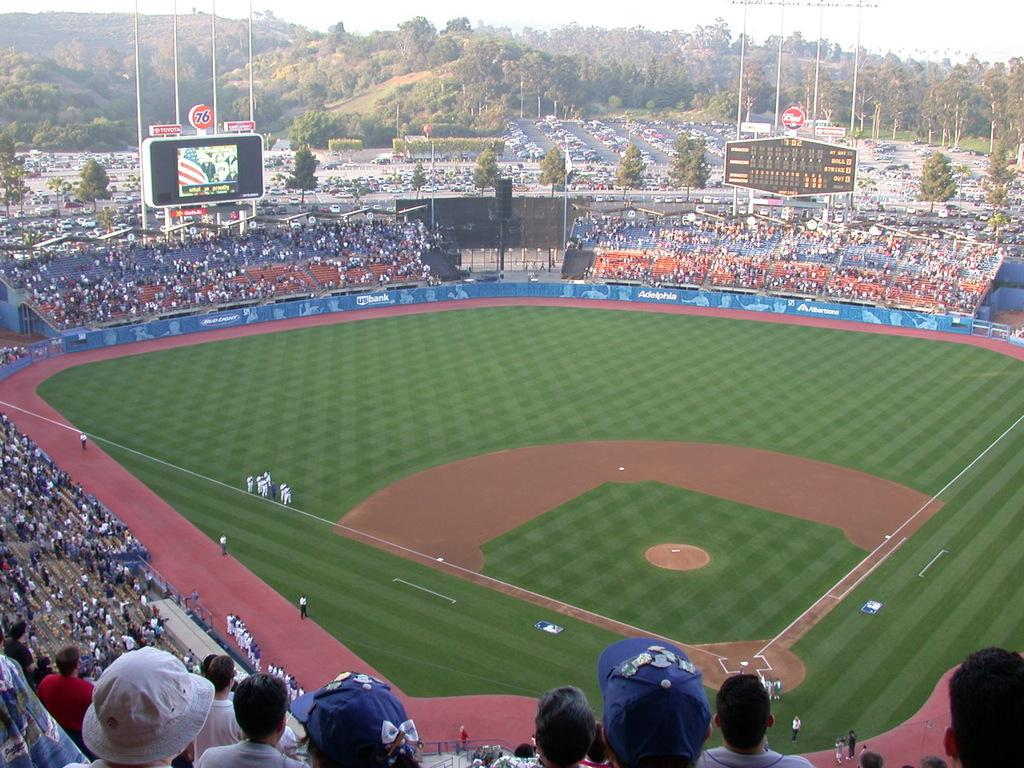What type of structure is visible in the image? There is a stadium in the image. What is present on the stadium grounds? There is a screen, boards, poles, grass, people, hoardings, trees, vehicles, and sky visible in the image. What is written on the boards? Something is written on the boards, but the specific content is not mentioned in the facts. What objects can be seen in the image? There are objects in the image, but the specific objects are not mentioned in the facts. What type of jeans are being worn by the canvas in the image? There is no canvas or jeans present in the image. What theory is being discussed by the people in the image? The facts do not mention any specific theories being discussed by the people in the image. 